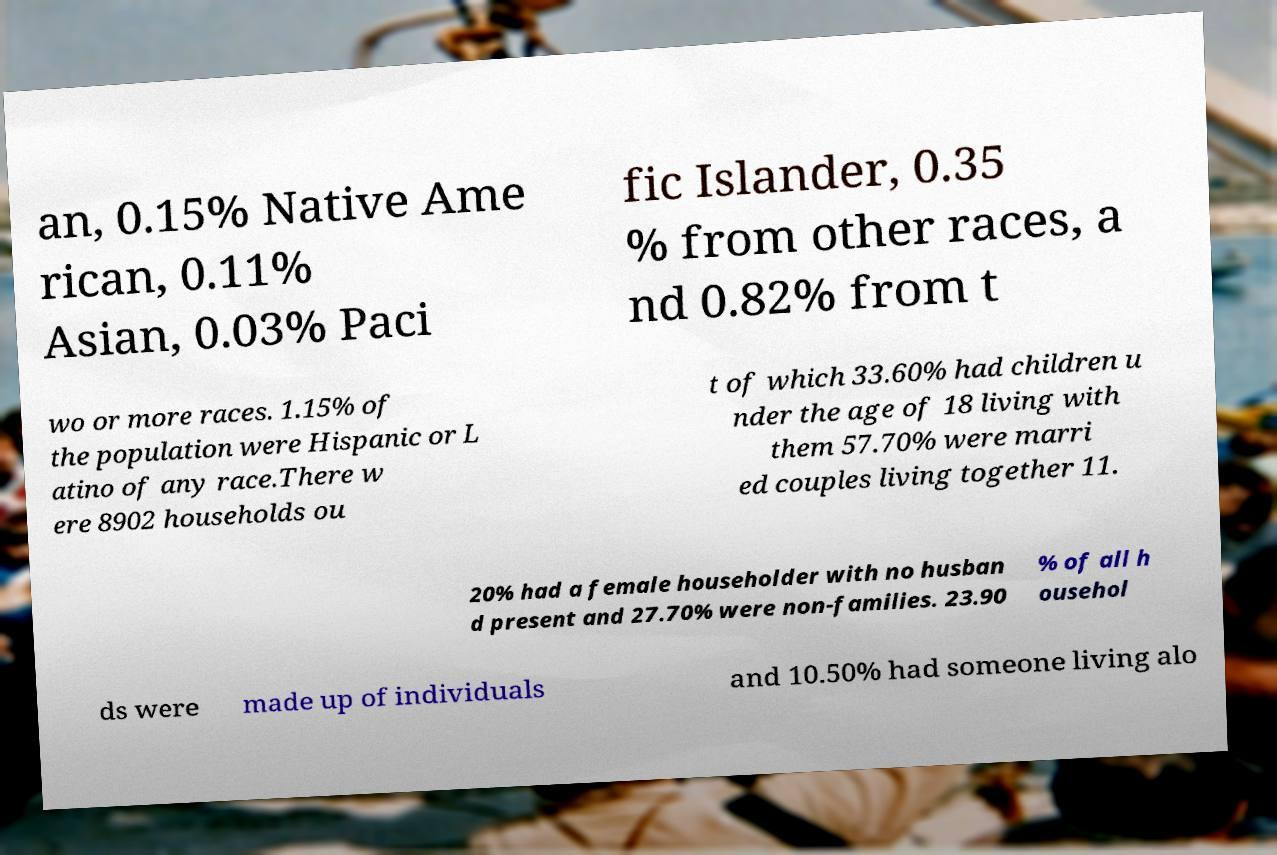I need the written content from this picture converted into text. Can you do that? an, 0.15% Native Ame rican, 0.11% Asian, 0.03% Paci fic Islander, 0.35 % from other races, a nd 0.82% from t wo or more races. 1.15% of the population were Hispanic or L atino of any race.There w ere 8902 households ou t of which 33.60% had children u nder the age of 18 living with them 57.70% were marri ed couples living together 11. 20% had a female householder with no husban d present and 27.70% were non-families. 23.90 % of all h ousehol ds were made up of individuals and 10.50% had someone living alo 